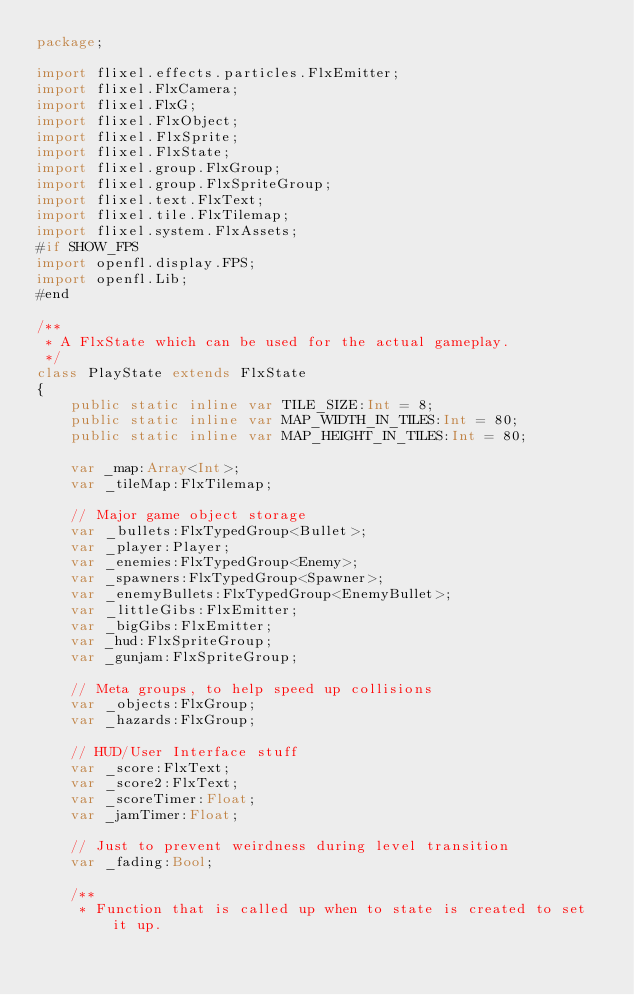<code> <loc_0><loc_0><loc_500><loc_500><_Haxe_>package;

import flixel.effects.particles.FlxEmitter;
import flixel.FlxCamera;
import flixel.FlxG;
import flixel.FlxObject;
import flixel.FlxSprite;
import flixel.FlxState;
import flixel.group.FlxGroup;
import flixel.group.FlxSpriteGroup;
import flixel.text.FlxText;
import flixel.tile.FlxTilemap;
import flixel.system.FlxAssets;
#if SHOW_FPS
import openfl.display.FPS;
import openfl.Lib;
#end

/**
 * A FlxState which can be used for the actual gameplay.
 */
class PlayState extends FlxState
{
	public static inline var TILE_SIZE:Int = 8;
	public static inline var MAP_WIDTH_IN_TILES:Int = 80;
	public static inline var MAP_HEIGHT_IN_TILES:Int = 80;

	var _map:Array<Int>;
	var _tileMap:FlxTilemap;

	// Major game object storage
	var _bullets:FlxTypedGroup<Bullet>;
	var _player:Player;
	var _enemies:FlxTypedGroup<Enemy>;
	var _spawners:FlxTypedGroup<Spawner>;
	var _enemyBullets:FlxTypedGroup<EnemyBullet>;
	var _littleGibs:FlxEmitter;
	var _bigGibs:FlxEmitter;
	var _hud:FlxSpriteGroup;
	var _gunjam:FlxSpriteGroup;

	// Meta groups, to help speed up collisions
	var _objects:FlxGroup;
	var _hazards:FlxGroup;

	// HUD/User Interface stuff
	var _score:FlxText;
	var _score2:FlxText;
	var _scoreTimer:Float;
	var _jamTimer:Float;

	// Just to prevent weirdness during level transition
	var _fading:Bool;

	/**
	 * Function that is called up when to state is created to set it up.</code> 